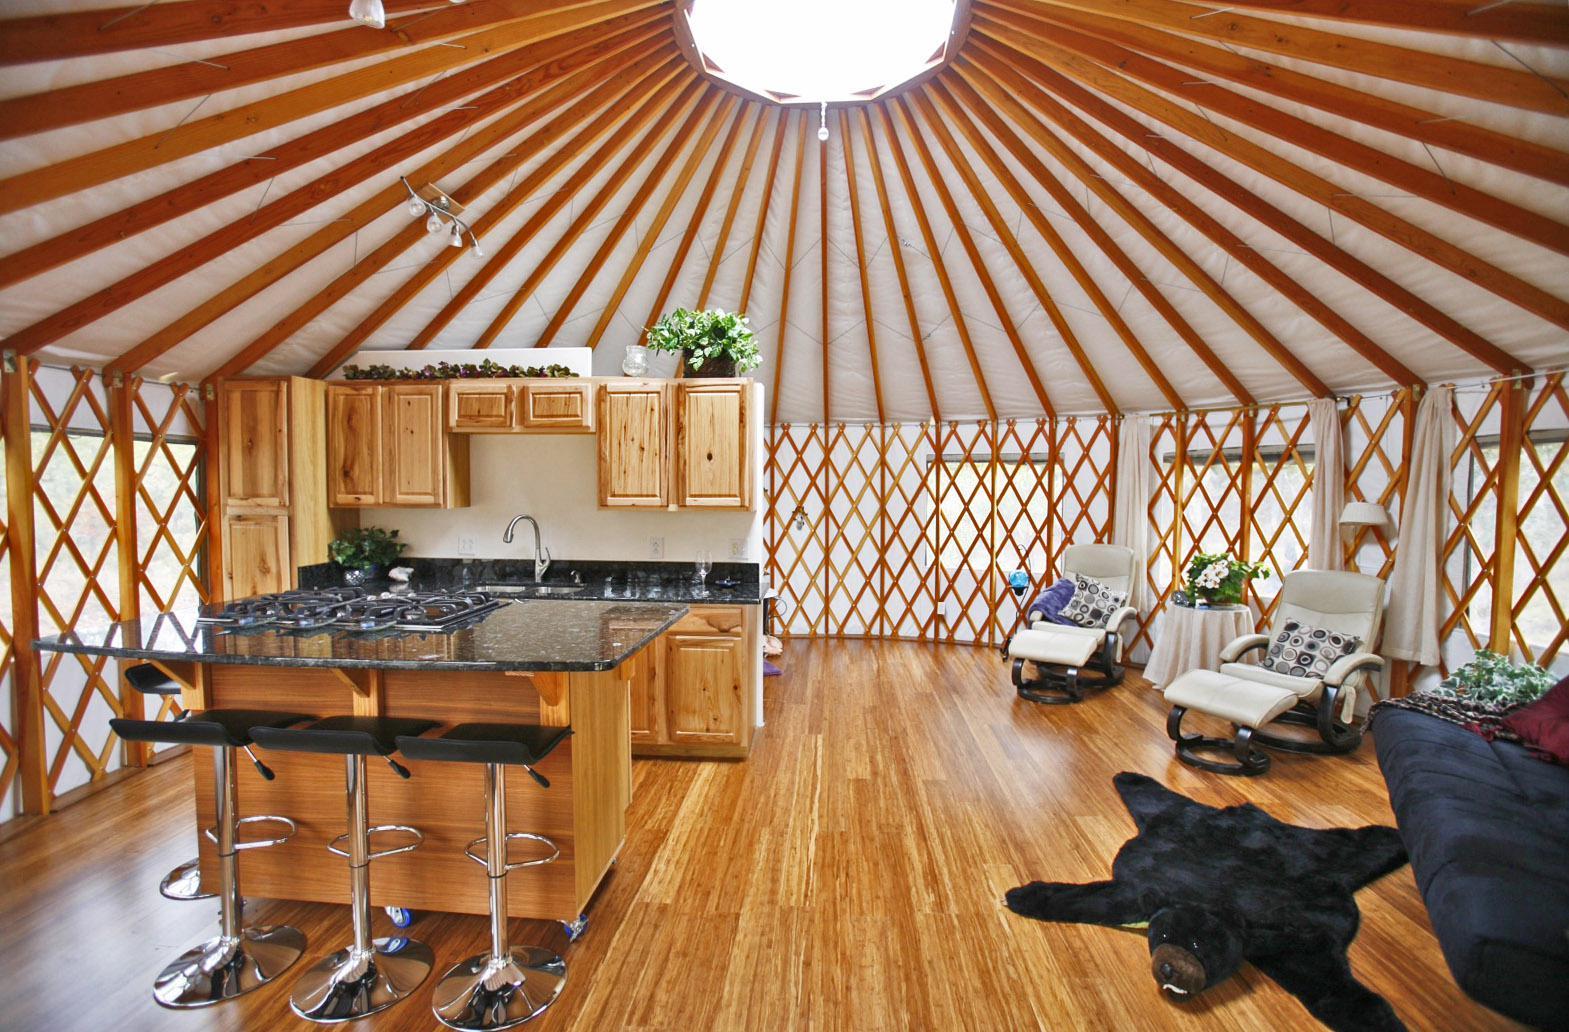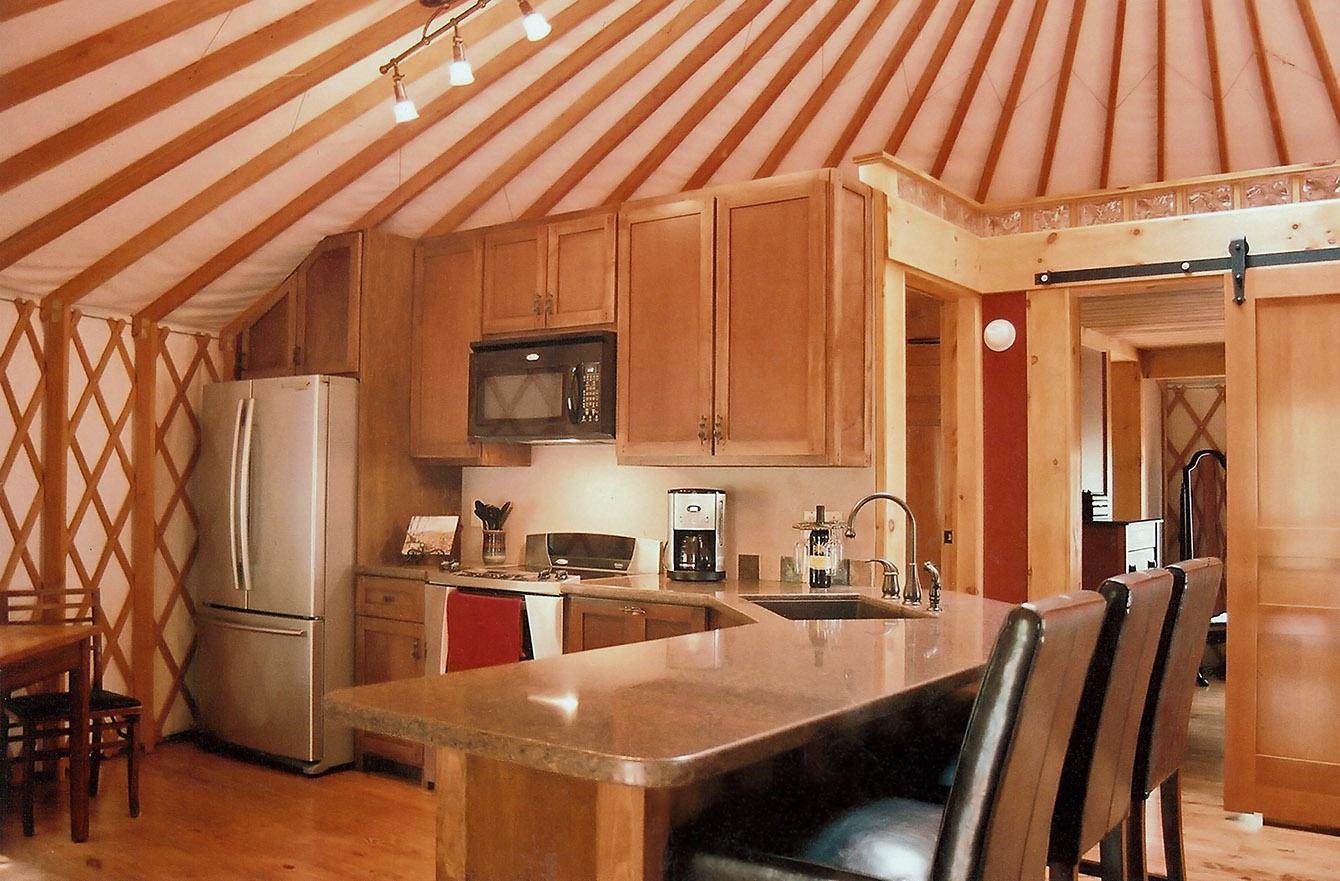The first image is the image on the left, the second image is the image on the right. Analyze the images presented: Is the assertion "One of the images shows a second floor balcony area with a wooden railing." valid? Answer yes or no. No. 